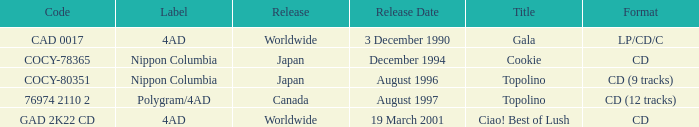What Label released an album in August 1996? Nippon Columbia. 